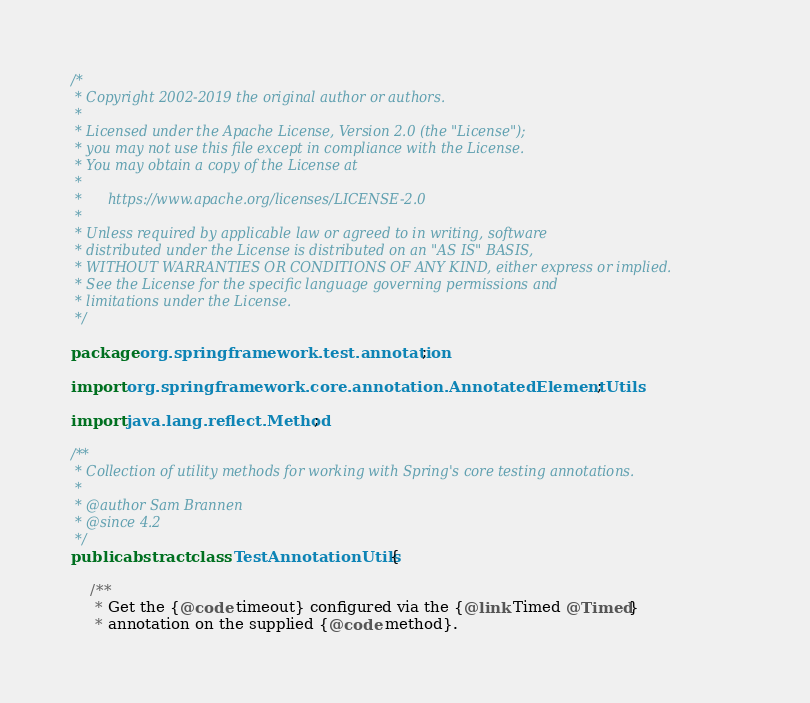Convert code to text. <code><loc_0><loc_0><loc_500><loc_500><_Java_>/*
 * Copyright 2002-2019 the original author or authors.
 *
 * Licensed under the Apache License, Version 2.0 (the "License");
 * you may not use this file except in compliance with the License.
 * You may obtain a copy of the License at
 *
 *      https://www.apache.org/licenses/LICENSE-2.0
 *
 * Unless required by applicable law or agreed to in writing, software
 * distributed under the License is distributed on an "AS IS" BASIS,
 * WITHOUT WARRANTIES OR CONDITIONS OF ANY KIND, either express or implied.
 * See the License for the specific language governing permissions and
 * limitations under the License.
 */

package org.springframework.test.annotation;

import org.springframework.core.annotation.AnnotatedElementUtils;

import java.lang.reflect.Method;

/**
 * Collection of utility methods for working with Spring's core testing annotations.
 *
 * @author Sam Brannen
 * @since 4.2
 */
public abstract class TestAnnotationUtils {

	/**
	 * Get the {@code timeout} configured via the {@link Timed @Timed}
	 * annotation on the supplied {@code method}.</code> 